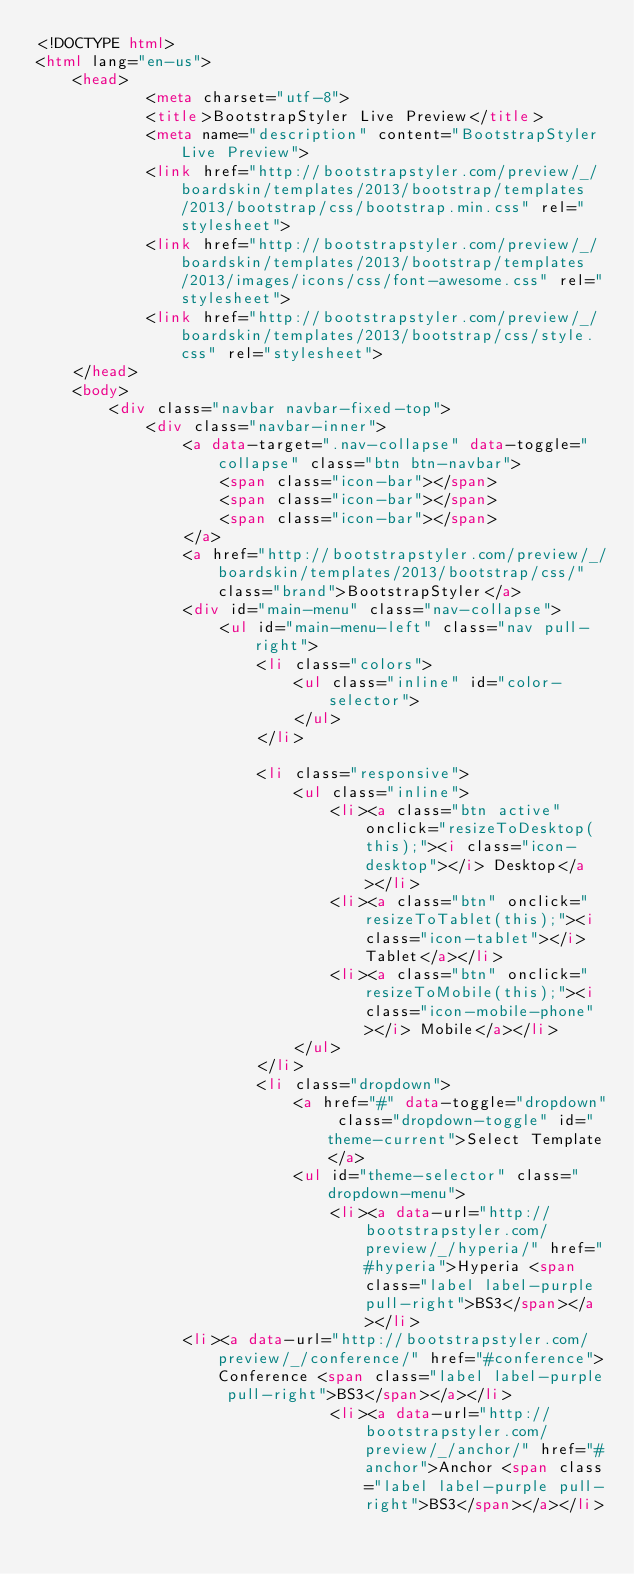<code> <loc_0><loc_0><loc_500><loc_500><_HTML_><!DOCTYPE html>
<html lang="en-us">
    <head>
            <meta charset="utf-8">
            <title>BootstrapStyler Live Preview</title>
            <meta name="description" content="BootstrapStyler Live Preview">
            <link href="http://bootstrapstyler.com/preview/_/boardskin/templates/2013/bootstrap/templates/2013/bootstrap/css/bootstrap.min.css" rel="stylesheet">
            <link href="http://bootstrapstyler.com/preview/_/boardskin/templates/2013/bootstrap/templates/2013/images/icons/css/font-awesome.css" rel="stylesheet">
            <link href="http://bootstrapstyler.com/preview/_/boardskin/templates/2013/bootstrap/css/style.css" rel="stylesheet">
    </head>
    <body>
        <div class="navbar navbar-fixed-top">
            <div class="navbar-inner">
                <a data-target=".nav-collapse" data-toggle="collapse" class="btn btn-navbar">
                    <span class="icon-bar"></span>
                    <span class="icon-bar"></span>
                    <span class="icon-bar"></span>
                </a>
                <a href="http://bootstrapstyler.com/preview/_/boardskin/templates/2013/bootstrap/css/" class="brand">BootstrapStyler</a>
                <div id="main-menu" class="nav-collapse">
                    <ul id="main-menu-left" class="nav pull-right">
                        <li class="colors">
                            <ul class="inline" id="color-selector">
                            </ul>
                        </li>

                        <li class="responsive">
                            <ul class="inline">
                                <li><a class="btn active" onclick="resizeToDesktop(this);"><i class="icon-desktop"></i> Desktop</a></li>
                                <li><a class="btn" onclick="resizeToTablet(this);"><i class="icon-tablet"></i> Tablet</a></li>
                                <li><a class="btn" onclick="resizeToMobile(this);"><i class="icon-mobile-phone"></i> Mobile</a></li>
                            </ul>
                        </li>
                        <li class="dropdown">
                            <a href="#" data-toggle="dropdown" class="dropdown-toggle" id="theme-current">Select Template</a>
                            <ul id="theme-selector" class="dropdown-menu">
                                <li><a data-url="http://bootstrapstyler.com/preview/_/hyperia/" href="#hyperia">Hyperia <span class="label label-purple pull-right">BS3</span></a></li>
								<li><a data-url="http://bootstrapstyler.com/preview/_/conference/" href="#conference">Conference <span class="label label-purple pull-right">BS3</span></a></li>
                                <li><a data-url="http://bootstrapstyler.com/preview/_/anchor/" href="#anchor">Anchor <span class="label label-purple pull-right">BS3</span></a></li></code> 